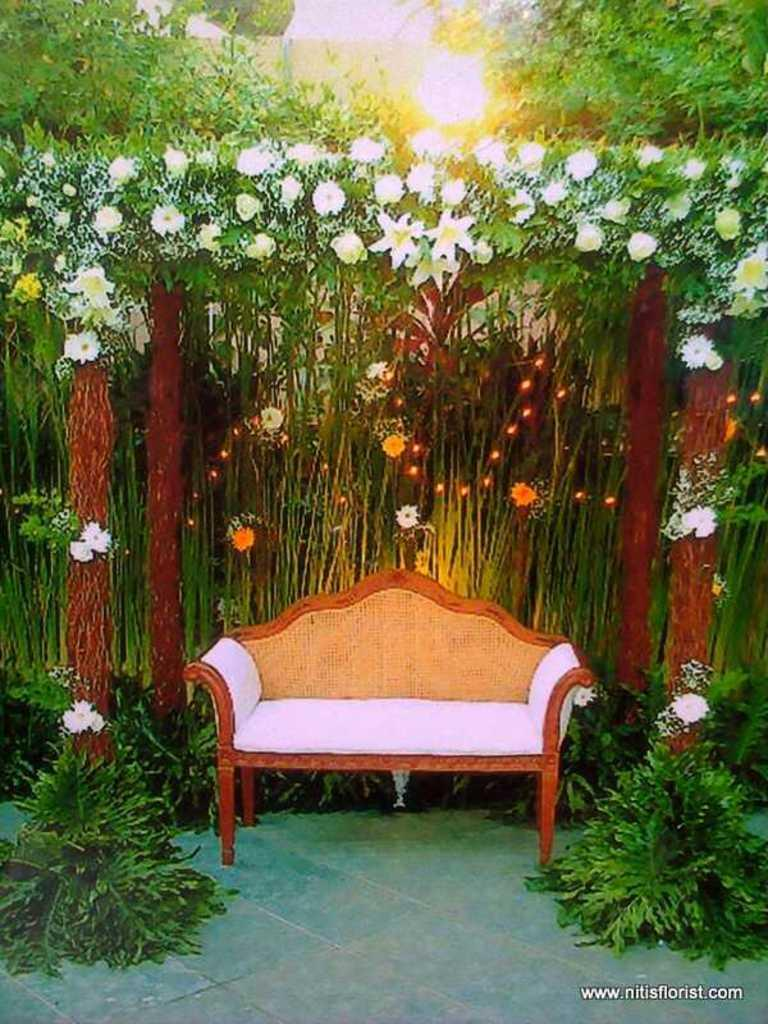What is the main theme of the picture? The picture has a greenery theme, as it is decorated with flowers. What type of furniture is present in the image? There is a sofa in the image. Are there any plants visible in the picture? Yes, there are plants near the chair. What type of produce is being offered by the crook in the image? There is no crook or produce present in the image. What is the name of the son who is sitting on the sofa in the image? There is no person, let alone a son, sitting on the sofa in the image. 